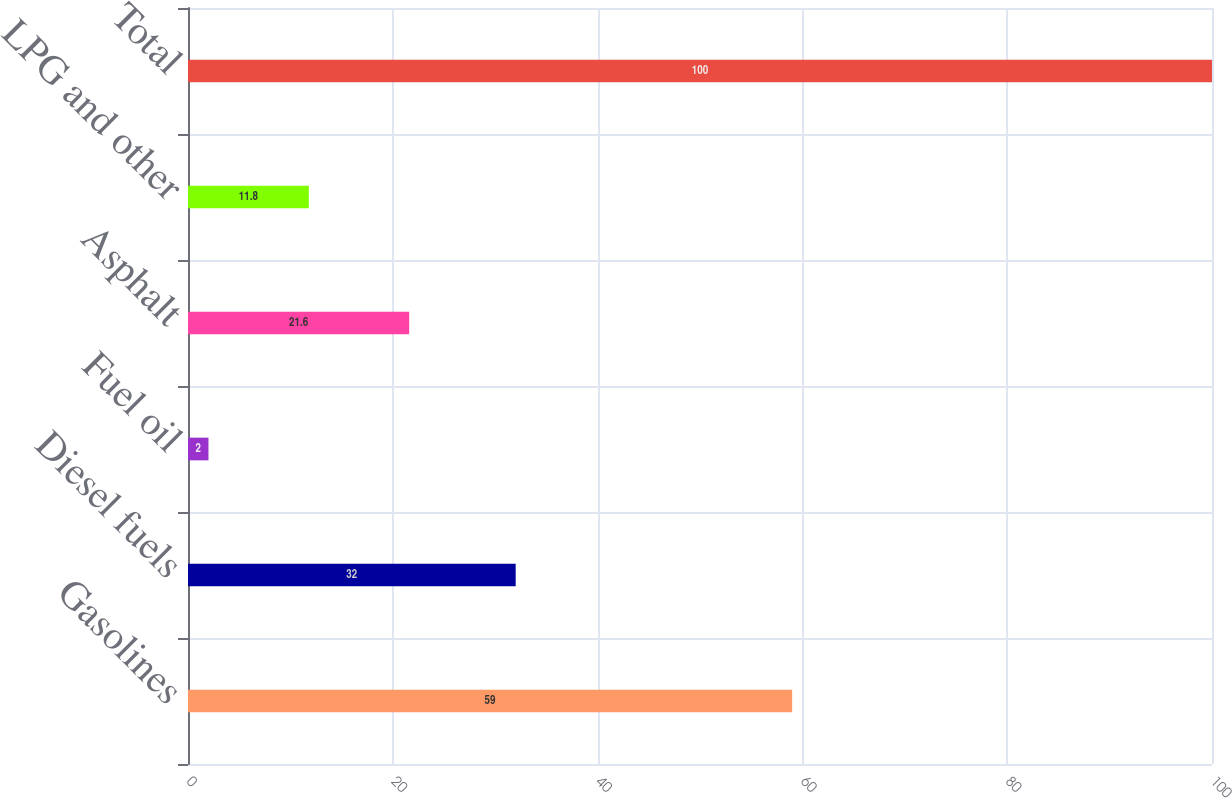Convert chart. <chart><loc_0><loc_0><loc_500><loc_500><bar_chart><fcel>Gasolines<fcel>Diesel fuels<fcel>Fuel oil<fcel>Asphalt<fcel>LPG and other<fcel>Total<nl><fcel>59<fcel>32<fcel>2<fcel>21.6<fcel>11.8<fcel>100<nl></chart> 